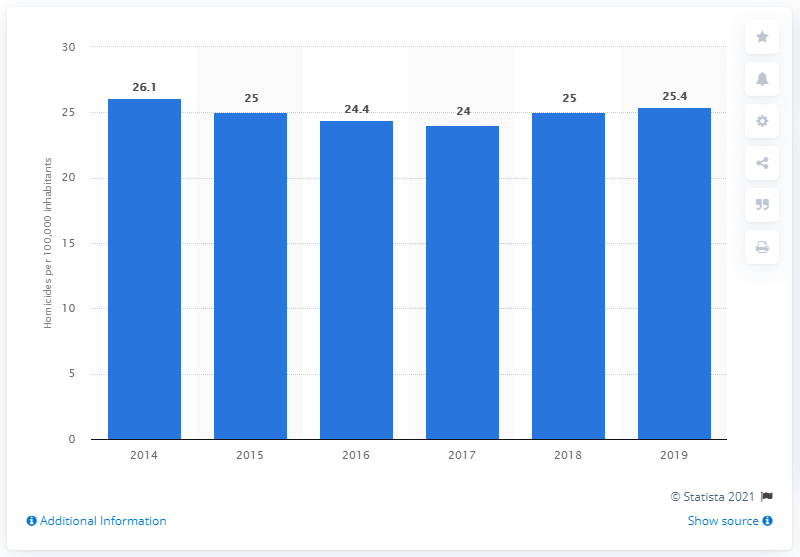Identify some key points in this picture. In 2019, there were approximately 25.4 homicides per 100,000 people in Colombia. 